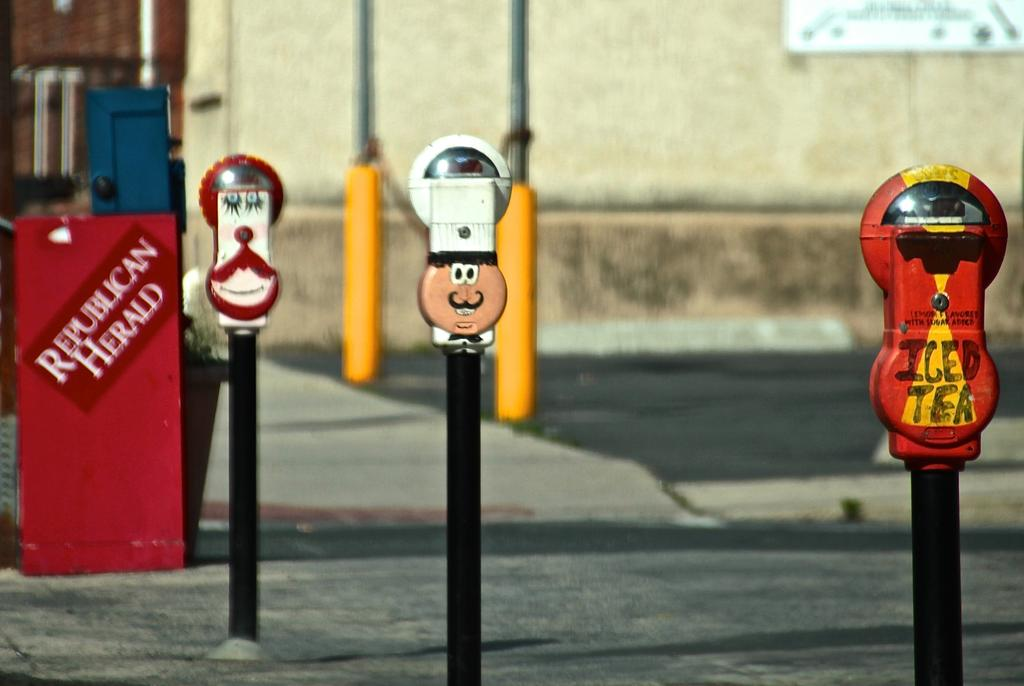<image>
Create a compact narrative representing the image presented. A red newspaper box labeled Republican Herald behind some decorative parking meters. 